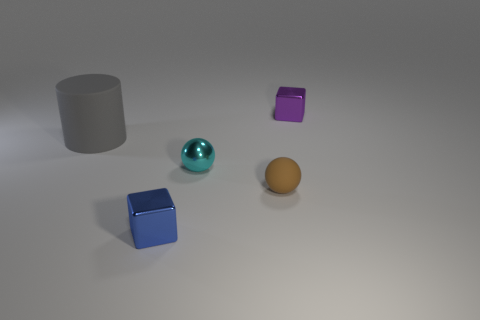Subtract 1 spheres. How many spheres are left? 1 Add 1 tiny blue shiny things. How many objects exist? 6 Subtract 0 blue cylinders. How many objects are left? 5 Subtract all spheres. How many objects are left? 3 Subtract all gray cubes. Subtract all gray balls. How many cubes are left? 2 Subtract all cyan metallic blocks. Subtract all tiny cyan objects. How many objects are left? 4 Add 5 tiny brown rubber spheres. How many tiny brown rubber spheres are left? 6 Add 3 big rubber objects. How many big rubber objects exist? 4 